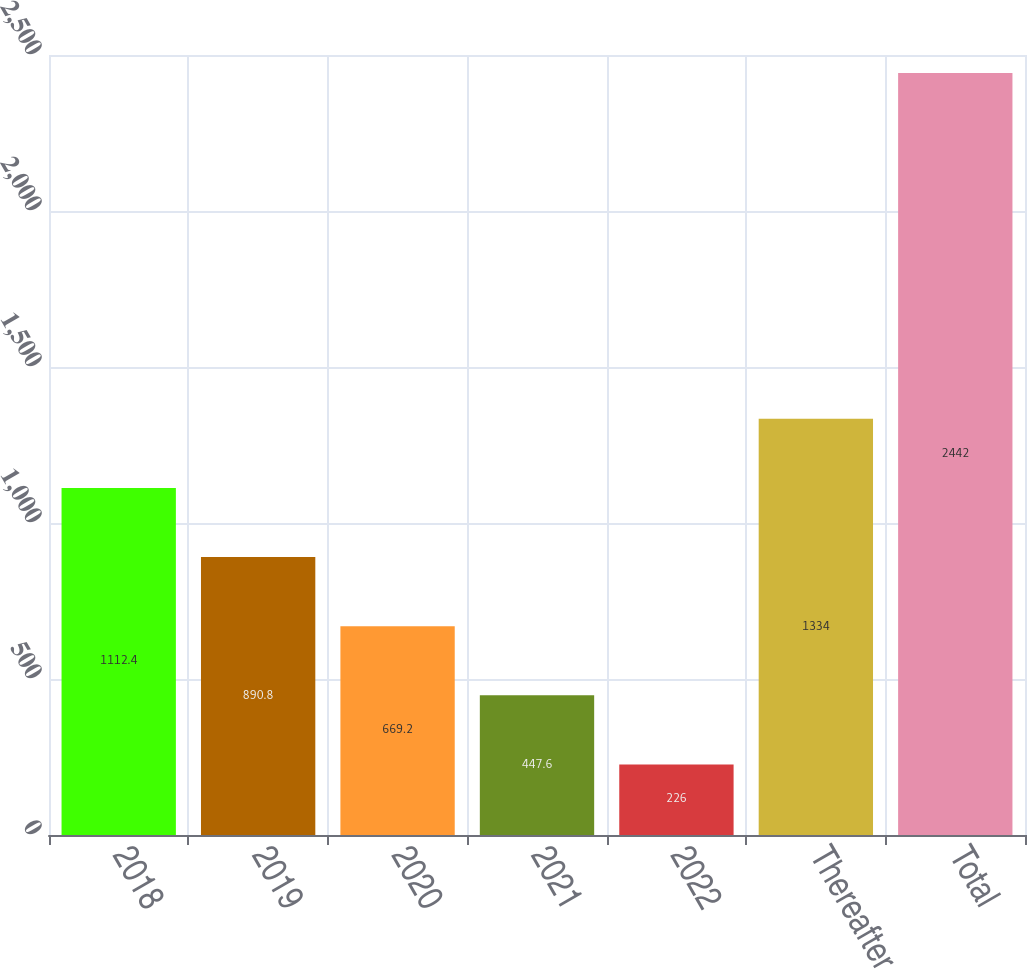<chart> <loc_0><loc_0><loc_500><loc_500><bar_chart><fcel>2018<fcel>2019<fcel>2020<fcel>2021<fcel>2022<fcel>Thereafter<fcel>Total<nl><fcel>1112.4<fcel>890.8<fcel>669.2<fcel>447.6<fcel>226<fcel>1334<fcel>2442<nl></chart> 